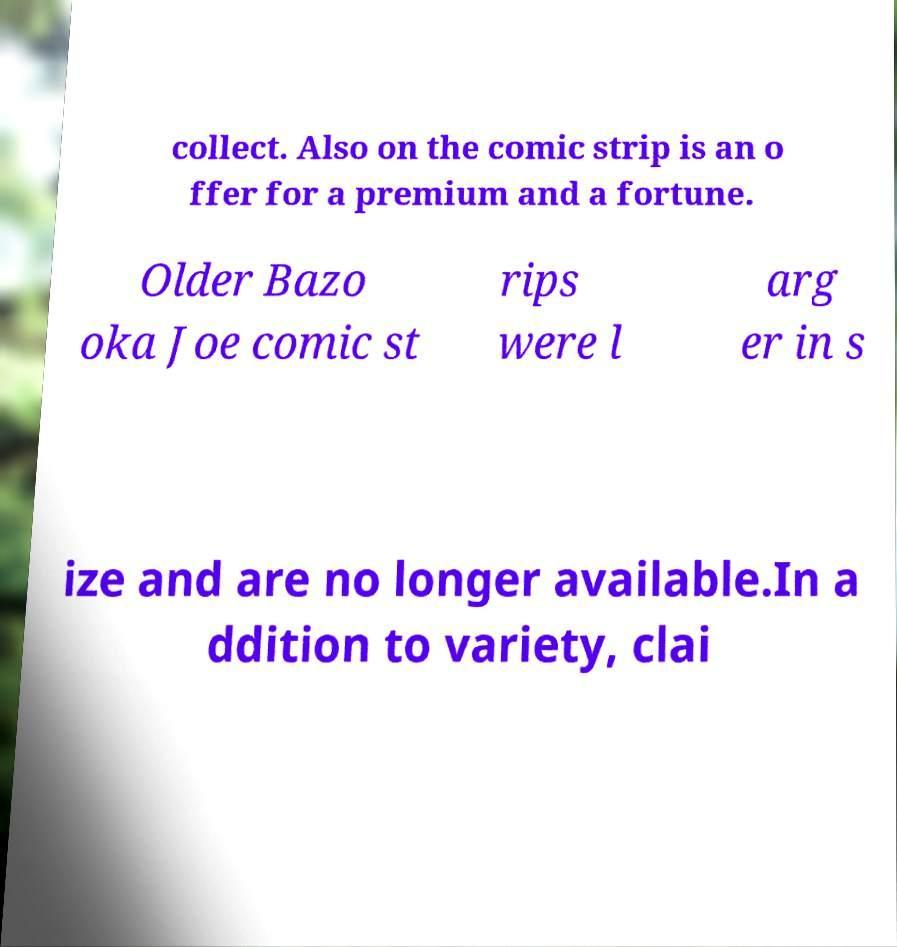Please read and relay the text visible in this image. What does it say? collect. Also on the comic strip is an o ffer for a premium and a fortune. Older Bazo oka Joe comic st rips were l arg er in s ize and are no longer available.In a ddition to variety, clai 